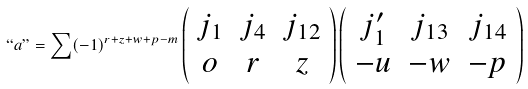<formula> <loc_0><loc_0><loc_500><loc_500>` ` a " = \sum ( - 1 ) ^ { r + z + w + p - m } \left ( \begin{array} { c c c } { { j _ { 1 } } } & { { j _ { 4 } } } & { { j _ { 1 2 } } } \\ { o } & { r } & { z } \end{array} \right ) \left ( \begin{array} { c c c } { { j _ { 1 } ^ { \prime } } } & { { j _ { 1 3 } } } & { { j _ { 1 4 } } } \\ { - u } & { - w } & { - p } \end{array} \right )</formula> 